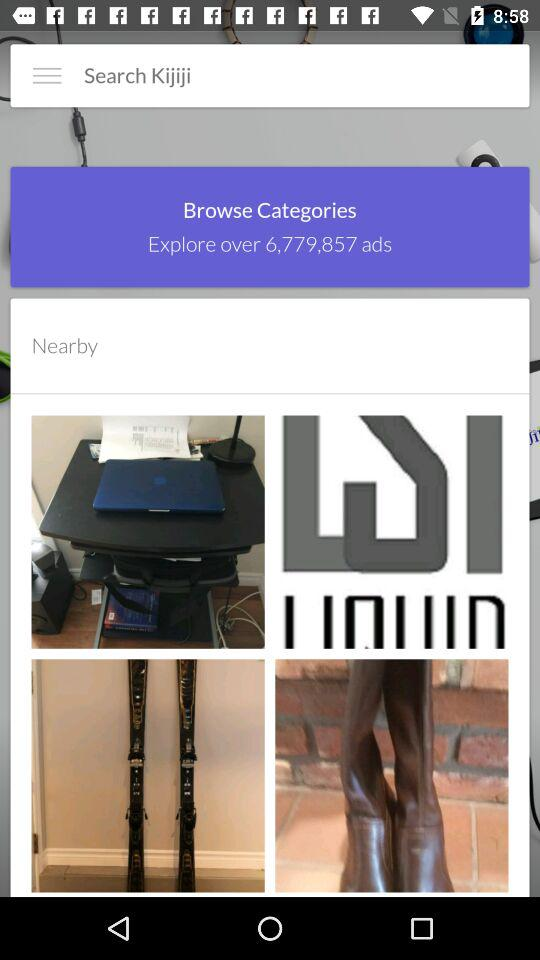What is the name of the application? The name of the application is "Kijiji". 